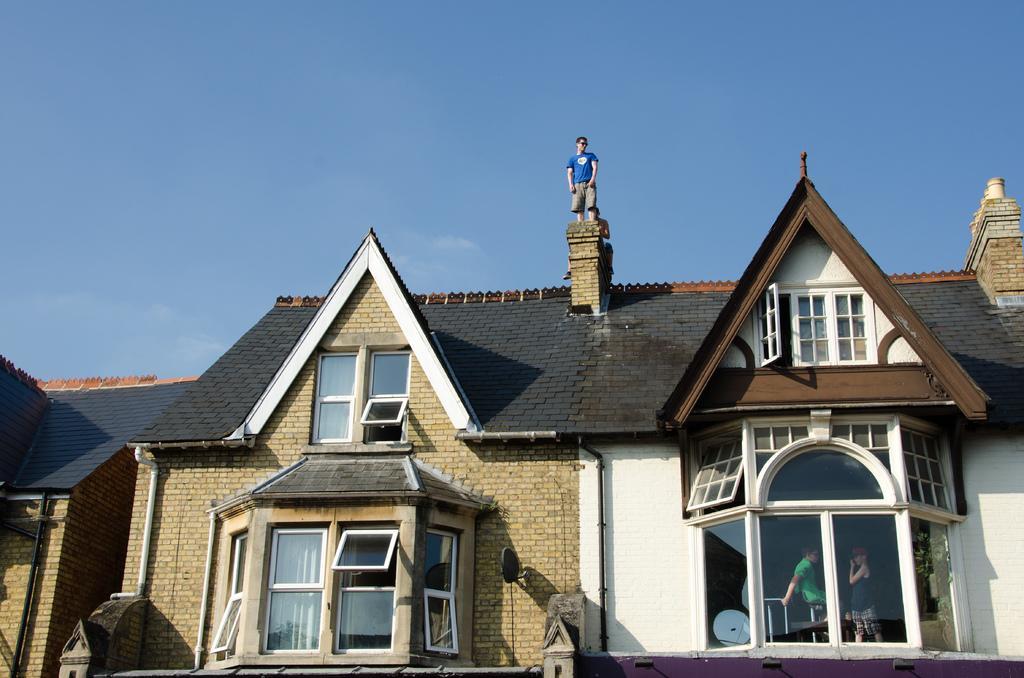Please provide a concise description of this image. In this image I can see houses, windows and three persons. In the background I can see the blue sky. This image is taken may be during a day. 